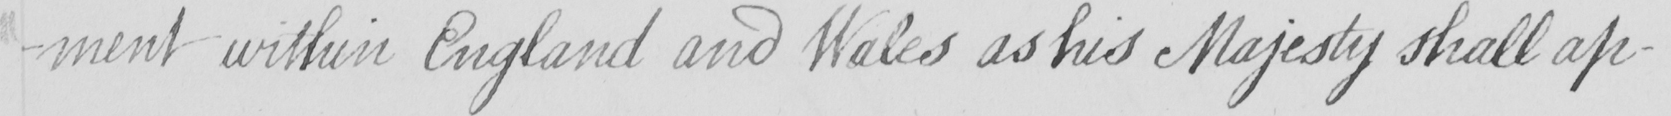Please provide the text content of this handwritten line. -ment within England and Wales as his Majesty shall ap- 